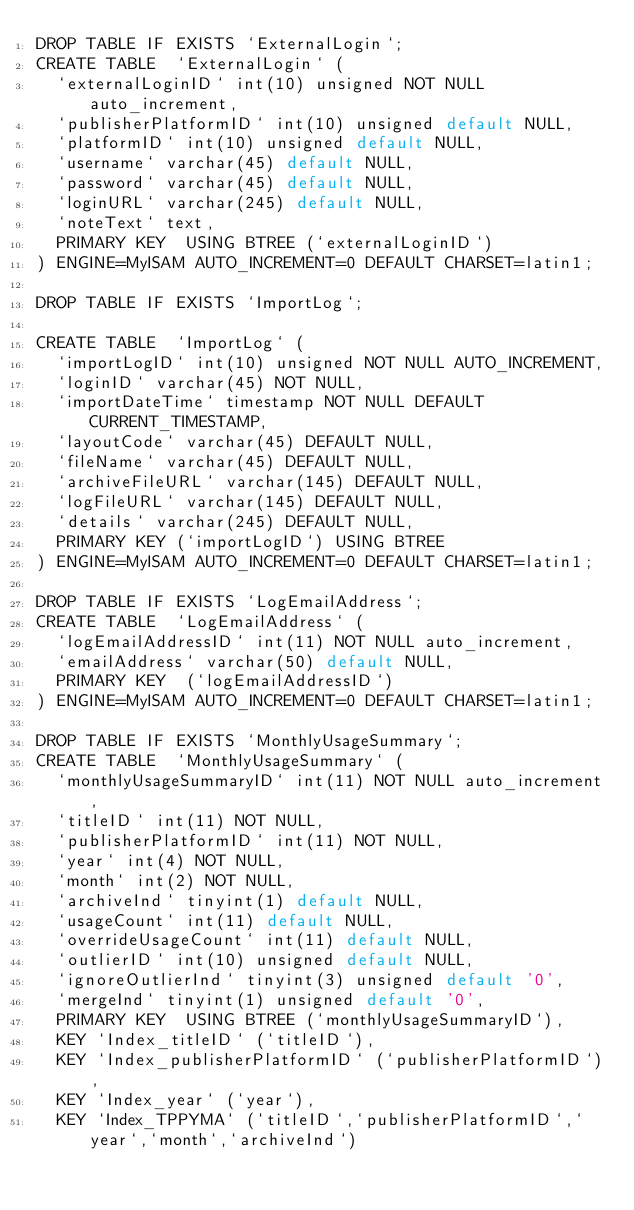<code> <loc_0><loc_0><loc_500><loc_500><_SQL_>DROP TABLE IF EXISTS `ExternalLogin`;
CREATE TABLE  `ExternalLogin` (
  `externalLoginID` int(10) unsigned NOT NULL auto_increment,
  `publisherPlatformID` int(10) unsigned default NULL,
  `platformID` int(10) unsigned default NULL,
  `username` varchar(45) default NULL,
  `password` varchar(45) default NULL,
  `loginURL` varchar(245) default NULL,
  `noteText` text,
  PRIMARY KEY  USING BTREE (`externalLoginID`)
) ENGINE=MyISAM AUTO_INCREMENT=0 DEFAULT CHARSET=latin1;

DROP TABLE IF EXISTS `ImportLog`;

CREATE TABLE  `ImportLog` (
  `importLogID` int(10) unsigned NOT NULL AUTO_INCREMENT,
  `loginID` varchar(45) NOT NULL,
  `importDateTime` timestamp NOT NULL DEFAULT CURRENT_TIMESTAMP,
  `layoutCode` varchar(45) DEFAULT NULL,
  `fileName` varchar(45) DEFAULT NULL,
  `archiveFileURL` varchar(145) DEFAULT NULL,
  `logFileURL` varchar(145) DEFAULT NULL,
  `details` varchar(245) DEFAULT NULL,
  PRIMARY KEY (`importLogID`) USING BTREE
) ENGINE=MyISAM AUTO_INCREMENT=0 DEFAULT CHARSET=latin1;

DROP TABLE IF EXISTS `LogEmailAddress`;
CREATE TABLE  `LogEmailAddress` (
  `logEmailAddressID` int(11) NOT NULL auto_increment,
  `emailAddress` varchar(50) default NULL,
  PRIMARY KEY  (`logEmailAddressID`)
) ENGINE=MyISAM AUTO_INCREMENT=0 DEFAULT CHARSET=latin1;

DROP TABLE IF EXISTS `MonthlyUsageSummary`;
CREATE TABLE  `MonthlyUsageSummary` (
  `monthlyUsageSummaryID` int(11) NOT NULL auto_increment,
  `titleID` int(11) NOT NULL,
  `publisherPlatformID` int(11) NOT NULL,
  `year` int(4) NOT NULL,
  `month` int(2) NOT NULL,
  `archiveInd` tinyint(1) default NULL,
  `usageCount` int(11) default NULL,
  `overrideUsageCount` int(11) default NULL,
  `outlierID` int(10) unsigned default NULL,
  `ignoreOutlierInd` tinyint(3) unsigned default '0',
  `mergeInd` tinyint(1) unsigned default '0',
  PRIMARY KEY  USING BTREE (`monthlyUsageSummaryID`),
  KEY `Index_titleID` (`titleID`),
  KEY `Index_publisherPlatformID` (`publisherPlatformID`),
  KEY `Index_year` (`year`),
  KEY `Index_TPPYMA` (`titleID`,`publisherPlatformID`,`year`,`month`,`archiveInd`)</code> 